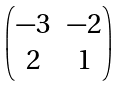<formula> <loc_0><loc_0><loc_500><loc_500>\begin{pmatrix} - 3 & - 2 \\ 2 & 1 \end{pmatrix}</formula> 